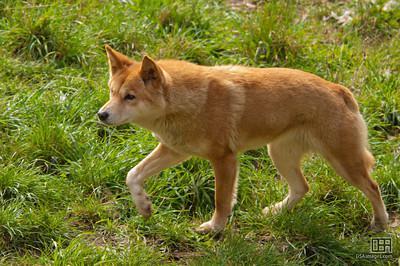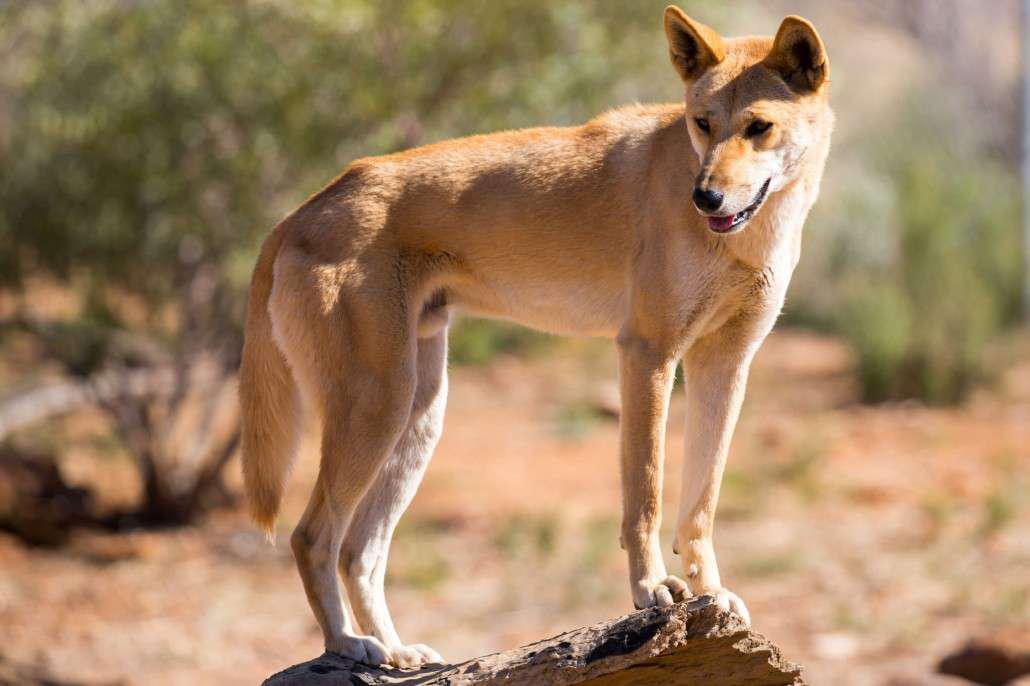The first image is the image on the left, the second image is the image on the right. Evaluate the accuracy of this statement regarding the images: "There are two dogs". Is it true? Answer yes or no. Yes. The first image is the image on the left, the second image is the image on the right. Examine the images to the left and right. Is the description "Left image shows two dogs and right image shows one dog." accurate? Answer yes or no. No. 